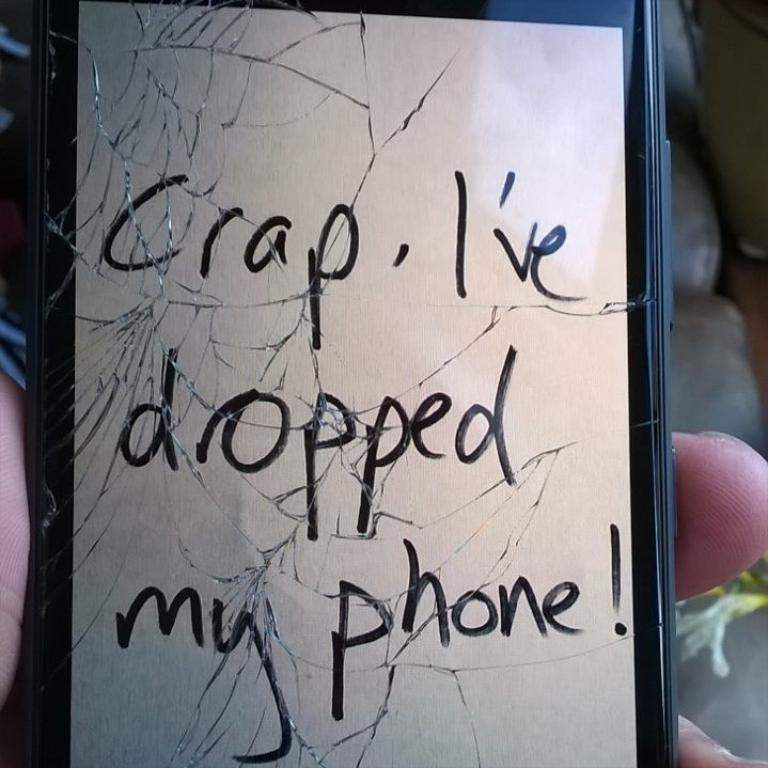What is the main subject of the image? There is a person in the image. What is the person holding in the image? The person is holding a mobile phone. Can you describe any text visible in the image? Yes, there is some text visible in the image. What day of the week is depicted in the image? There is no indication of a specific day of the week in the image. What is the cause of the person's expression in the image? The image does not provide enough information to determine the cause of the person's expression. 